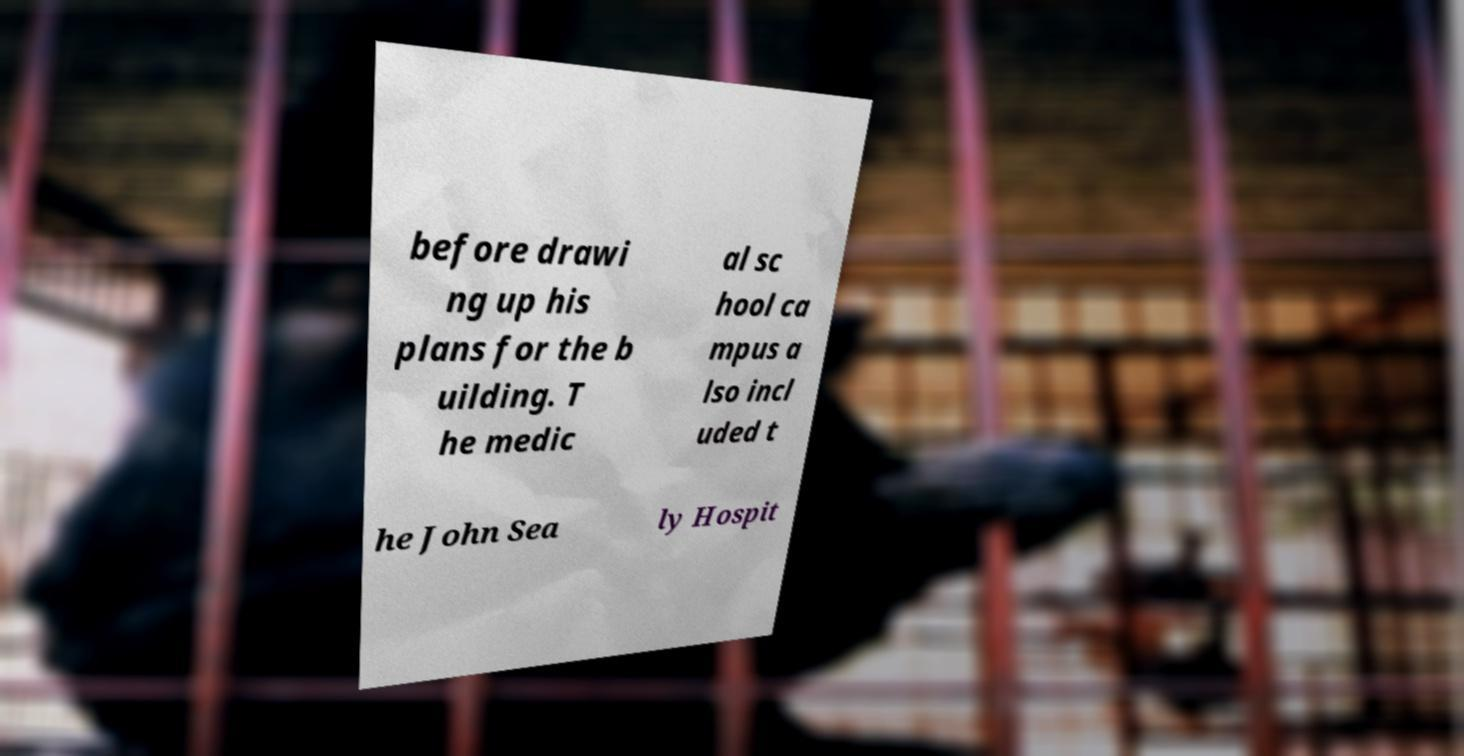Please read and relay the text visible in this image. What does it say? before drawi ng up his plans for the b uilding. T he medic al sc hool ca mpus a lso incl uded t he John Sea ly Hospit 